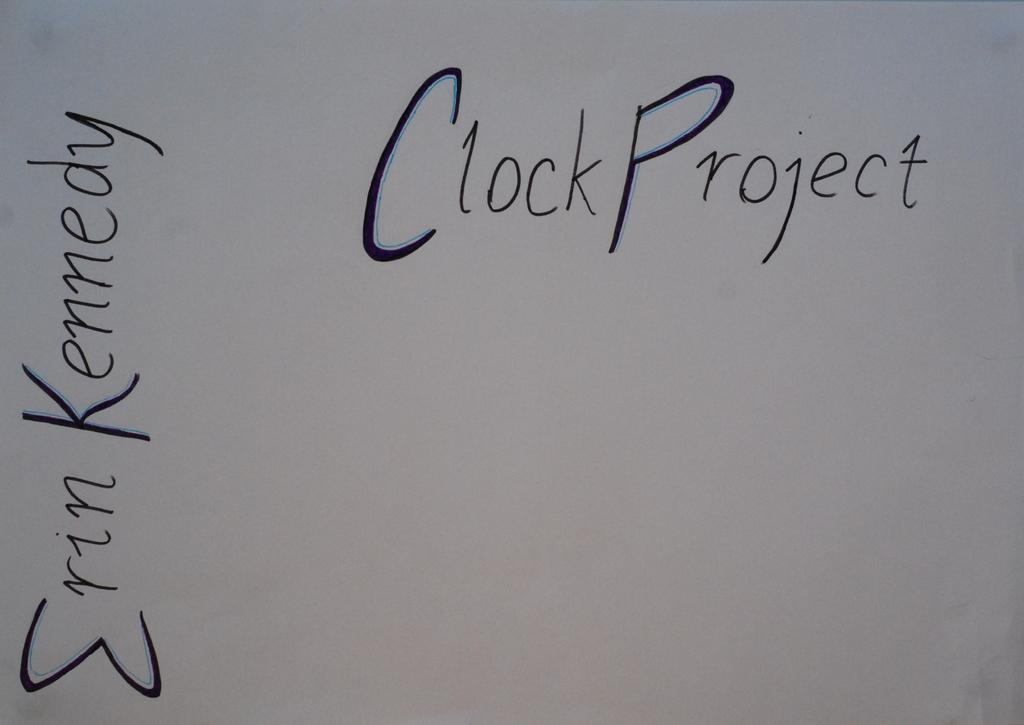What is present on the paper in the image? There is text on a paper in the image. What type of wealth is the band discussing with the passenger in the image? There is no band, passenger, or discussion about wealth present in the image; it only features text on a paper. 